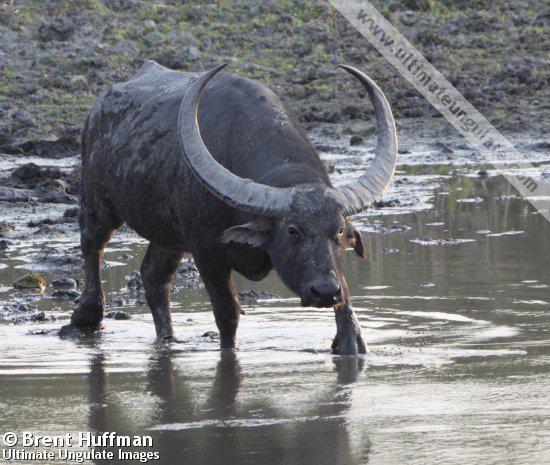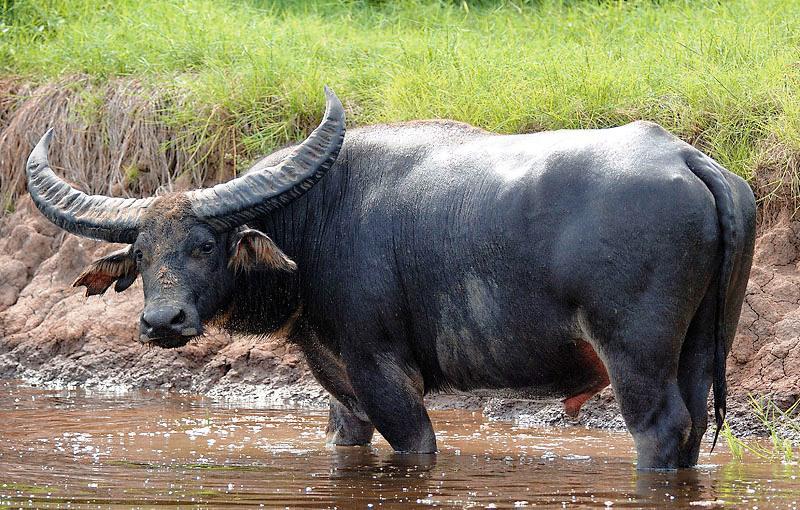The first image is the image on the left, the second image is the image on the right. For the images shown, is this caption "An image contains a water buffalo standing in water." true? Answer yes or no. Yes. The first image is the image on the left, the second image is the image on the right. Examine the images to the left and right. Is the description "Two water buffalos are standing in water." accurate? Answer yes or no. Yes. 